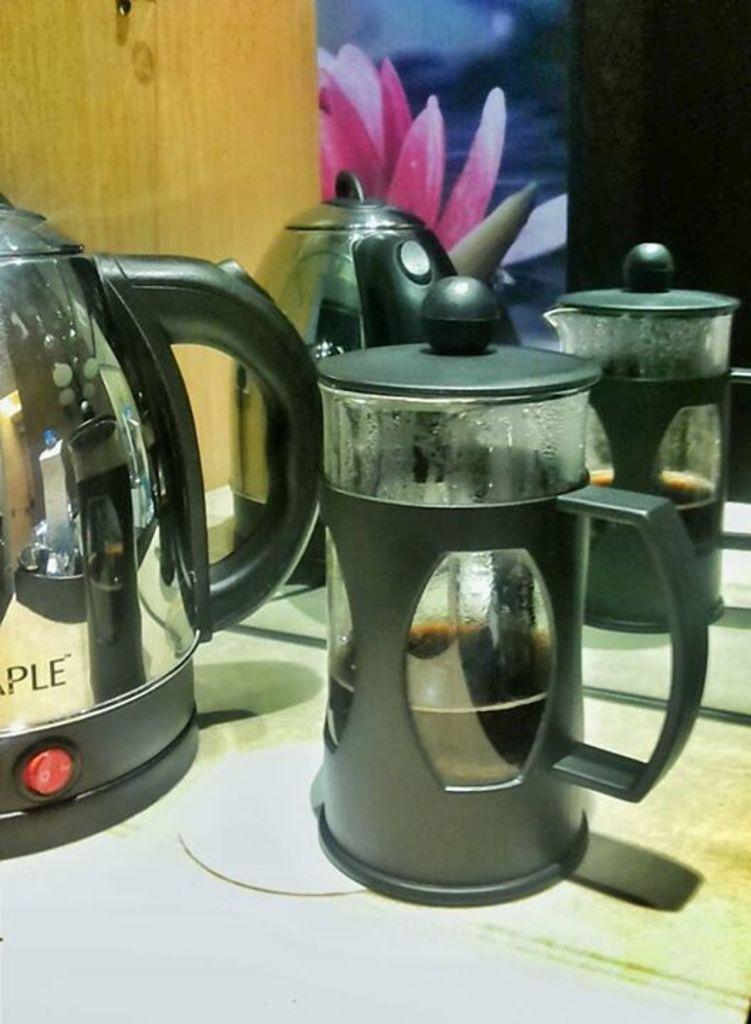Could you give a brief overview of what you see in this image? In this image I can see two kettles and two black colour things in the front. On the left side of the image I can see something is written on the kettle. In the background I can see a poster and on it I can see a picture of a flower. 